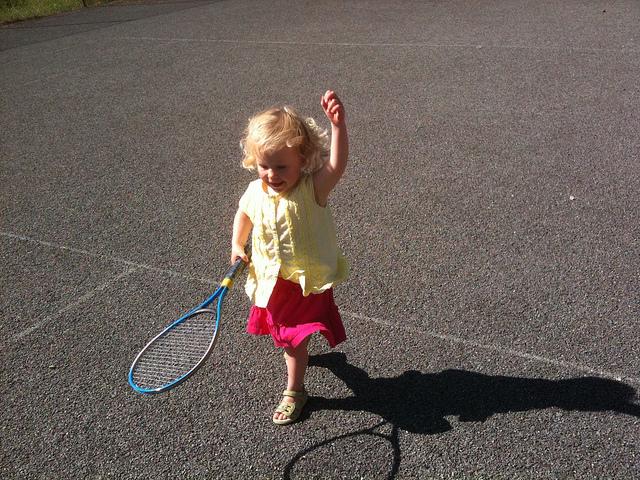What is she playing?
Give a very brief answer. Tennis. What color is the child's hair?
Short answer required. Blonde. What color is the girls hair?
Answer briefly. Blonde. 